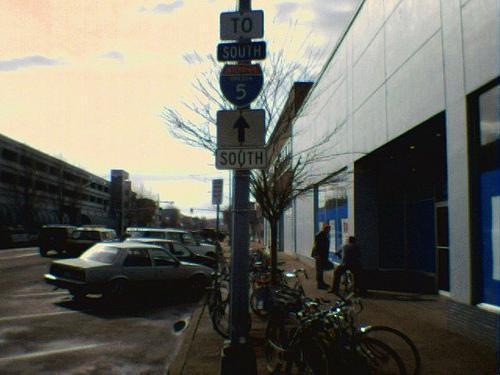How many highway signs are there?
Give a very brief answer. 1. 